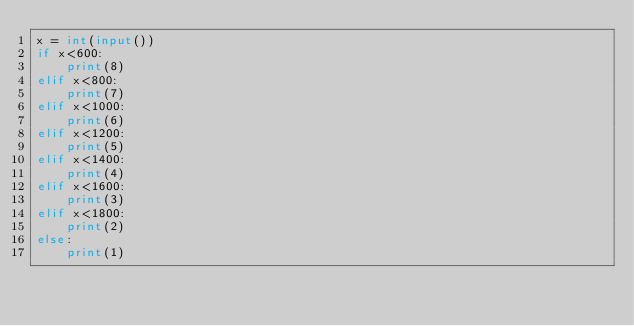<code> <loc_0><loc_0><loc_500><loc_500><_Python_>x = int(input())
if x<600:
    print(8)
elif x<800:
    print(7)
elif x<1000:
    print(6)
elif x<1200:
    print(5)
elif x<1400:
    print(4)
elif x<1600:
    print(3)
elif x<1800:
    print(2)
else:
    print(1)</code> 